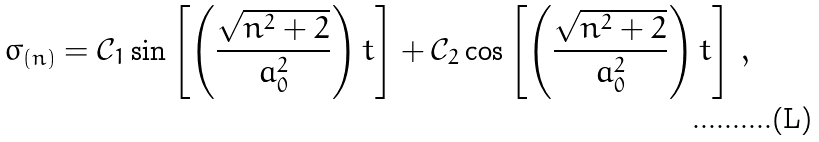<formula> <loc_0><loc_0><loc_500><loc_500>\sigma _ { ( n ) } = \mathcal { C } _ { 1 } \sin \left [ \left ( { \frac { \sqrt { n ^ { 2 } + 2 } } { a _ { 0 } ^ { 2 } } } \right ) t \right ] + \mathcal { C } _ { 2 } \cos \left [ \left ( { \frac { \sqrt { n ^ { 2 } + 2 } } { a _ { 0 } ^ { 2 } } } \right ) t \right ] \, ,</formula> 